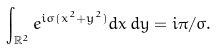<formula> <loc_0><loc_0><loc_500><loc_500>\int _ { \mathbb { R } ^ { 2 } } e ^ { i \sigma ( x ^ { 2 } + y ^ { 2 } ) } d x \, d y = i \pi / \sigma .</formula> 